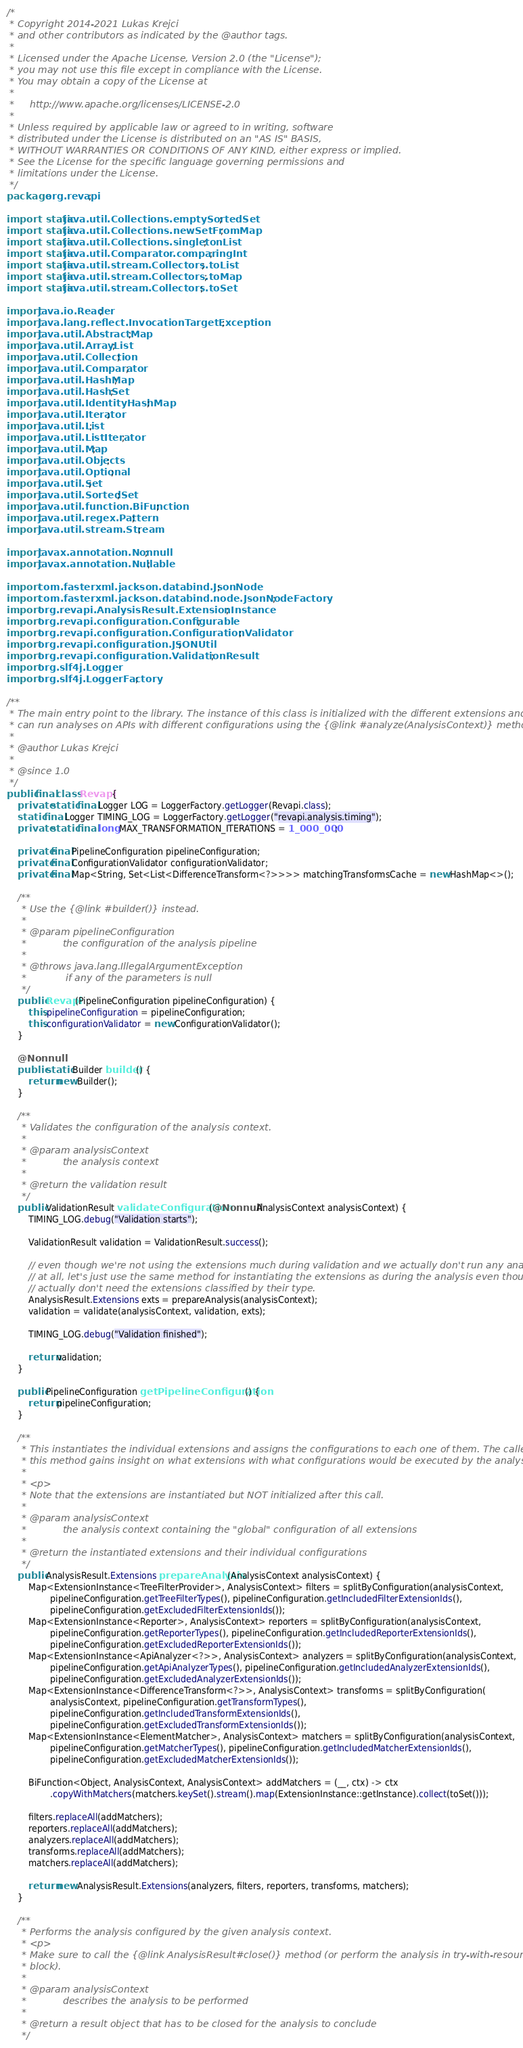Convert code to text. <code><loc_0><loc_0><loc_500><loc_500><_Java_>/*
 * Copyright 2014-2021 Lukas Krejci
 * and other contributors as indicated by the @author tags.
 *
 * Licensed under the Apache License, Version 2.0 (the "License");
 * you may not use this file except in compliance with the License.
 * You may obtain a copy of the License at
 *
 *     http://www.apache.org/licenses/LICENSE-2.0
 *
 * Unless required by applicable law or agreed to in writing, software
 * distributed under the License is distributed on an "AS IS" BASIS,
 * WITHOUT WARRANTIES OR CONDITIONS OF ANY KIND, either express or implied.
 * See the License for the specific language governing permissions and
 * limitations under the License.
 */
package org.revapi;

import static java.util.Collections.emptySortedSet;
import static java.util.Collections.newSetFromMap;
import static java.util.Collections.singletonList;
import static java.util.Comparator.comparingInt;
import static java.util.stream.Collectors.toList;
import static java.util.stream.Collectors.toMap;
import static java.util.stream.Collectors.toSet;

import java.io.Reader;
import java.lang.reflect.InvocationTargetException;
import java.util.AbstractMap;
import java.util.ArrayList;
import java.util.Collection;
import java.util.Comparator;
import java.util.HashMap;
import java.util.HashSet;
import java.util.IdentityHashMap;
import java.util.Iterator;
import java.util.List;
import java.util.ListIterator;
import java.util.Map;
import java.util.Objects;
import java.util.Optional;
import java.util.Set;
import java.util.SortedSet;
import java.util.function.BiFunction;
import java.util.regex.Pattern;
import java.util.stream.Stream;

import javax.annotation.Nonnull;
import javax.annotation.Nullable;

import com.fasterxml.jackson.databind.JsonNode;
import com.fasterxml.jackson.databind.node.JsonNodeFactory;
import org.revapi.AnalysisResult.ExtensionInstance;
import org.revapi.configuration.Configurable;
import org.revapi.configuration.ConfigurationValidator;
import org.revapi.configuration.JSONUtil;
import org.revapi.configuration.ValidationResult;
import org.slf4j.Logger;
import org.slf4j.LoggerFactory;

/**
 * The main entry point to the library. The instance of this class is initialized with the different extensions and then
 * can run analyses on APIs with different configurations using the {@link #analyze(AnalysisContext)} method.
 *
 * @author Lukas Krejci
 * 
 * @since 1.0
 */
public final class Revapi {
    private static final Logger LOG = LoggerFactory.getLogger(Revapi.class);
    static final Logger TIMING_LOG = LoggerFactory.getLogger("revapi.analysis.timing");
    private static final long MAX_TRANSFORMATION_ITERATIONS = 1_000_000;

    private final PipelineConfiguration pipelineConfiguration;
    private final ConfigurationValidator configurationValidator;
    private final Map<String, Set<List<DifferenceTransform<?>>>> matchingTransformsCache = new HashMap<>();

    /**
     * Use the {@link #builder()} instead.
     *
     * @param pipelineConfiguration
     *            the configuration of the analysis pipeline
     * 
     * @throws java.lang.IllegalArgumentException
     *             if any of the parameters is null
     */
    public Revapi(PipelineConfiguration pipelineConfiguration) {
        this.pipelineConfiguration = pipelineConfiguration;
        this.configurationValidator = new ConfigurationValidator();
    }

    @Nonnull
    public static Builder builder() {
        return new Builder();
    }

    /**
     * Validates the configuration of the analysis context.
     *
     * @param analysisContext
     *            the analysis context
     * 
     * @return the validation result
     */
    public ValidationResult validateConfiguration(@Nonnull AnalysisContext analysisContext) {
        TIMING_LOG.debug("Validation starts");

        ValidationResult validation = ValidationResult.success();

        // even though we're not using the extensions much during validation and we actually don't run any analysis
        // at all, let's just use the same method for instantiating the extensions as during the analysis even though we
        // actually don't need the extensions classified by their type.
        AnalysisResult.Extensions exts = prepareAnalysis(analysisContext);
        validation = validate(analysisContext, validation, exts);

        TIMING_LOG.debug("Validation finished");

        return validation;
    }

    public PipelineConfiguration getPipelineConfiguration() {
        return pipelineConfiguration;
    }

    /**
     * This instantiates the individual extensions and assigns the configurations to each one of them. The caller of
     * this method gains insight on what extensions with what configurations would be executed by the analysis.
     *
     * <p>
     * Note that the extensions are instantiated but NOT initialized after this call.
     *
     * @param analysisContext
     *            the analysis context containing the "global" configuration of all extensions
     * 
     * @return the instantiated extensions and their individual configurations
     */
    public AnalysisResult.Extensions prepareAnalysis(AnalysisContext analysisContext) {
        Map<ExtensionInstance<TreeFilterProvider>, AnalysisContext> filters = splitByConfiguration(analysisContext,
                pipelineConfiguration.getTreeFilterTypes(), pipelineConfiguration.getIncludedFilterExtensionIds(),
                pipelineConfiguration.getExcludedFilterExtensionIds());
        Map<ExtensionInstance<Reporter>, AnalysisContext> reporters = splitByConfiguration(analysisContext,
                pipelineConfiguration.getReporterTypes(), pipelineConfiguration.getIncludedReporterExtensionIds(),
                pipelineConfiguration.getExcludedReporterExtensionIds());
        Map<ExtensionInstance<ApiAnalyzer<?>>, AnalysisContext> analyzers = splitByConfiguration(analysisContext,
                pipelineConfiguration.getApiAnalyzerTypes(), pipelineConfiguration.getIncludedAnalyzerExtensionIds(),
                pipelineConfiguration.getExcludedAnalyzerExtensionIds());
        Map<ExtensionInstance<DifferenceTransform<?>>, AnalysisContext> transforms = splitByConfiguration(
                analysisContext, pipelineConfiguration.getTransformTypes(),
                pipelineConfiguration.getIncludedTransformExtensionIds(),
                pipelineConfiguration.getExcludedTransformExtensionIds());
        Map<ExtensionInstance<ElementMatcher>, AnalysisContext> matchers = splitByConfiguration(analysisContext,
                pipelineConfiguration.getMatcherTypes(), pipelineConfiguration.getIncludedMatcherExtensionIds(),
                pipelineConfiguration.getExcludedMatcherExtensionIds());

        BiFunction<Object, AnalysisContext, AnalysisContext> addMatchers = (__, ctx) -> ctx
                .copyWithMatchers(matchers.keySet().stream().map(ExtensionInstance::getInstance).collect(toSet()));

        filters.replaceAll(addMatchers);
        reporters.replaceAll(addMatchers);
        analyzers.replaceAll(addMatchers);
        transforms.replaceAll(addMatchers);
        matchers.replaceAll(addMatchers);

        return new AnalysisResult.Extensions(analyzers, filters, reporters, transforms, matchers);
    }

    /**
     * Performs the analysis configured by the given analysis context.
     * <p>
     * Make sure to call the {@link AnalysisResult#close()} method (or perform the analysis in try-with-resources
     * block).
     *
     * @param analysisContext
     *            describes the analysis to be performed
     * 
     * @return a result object that has to be closed for the analysis to conclude
     */</code> 